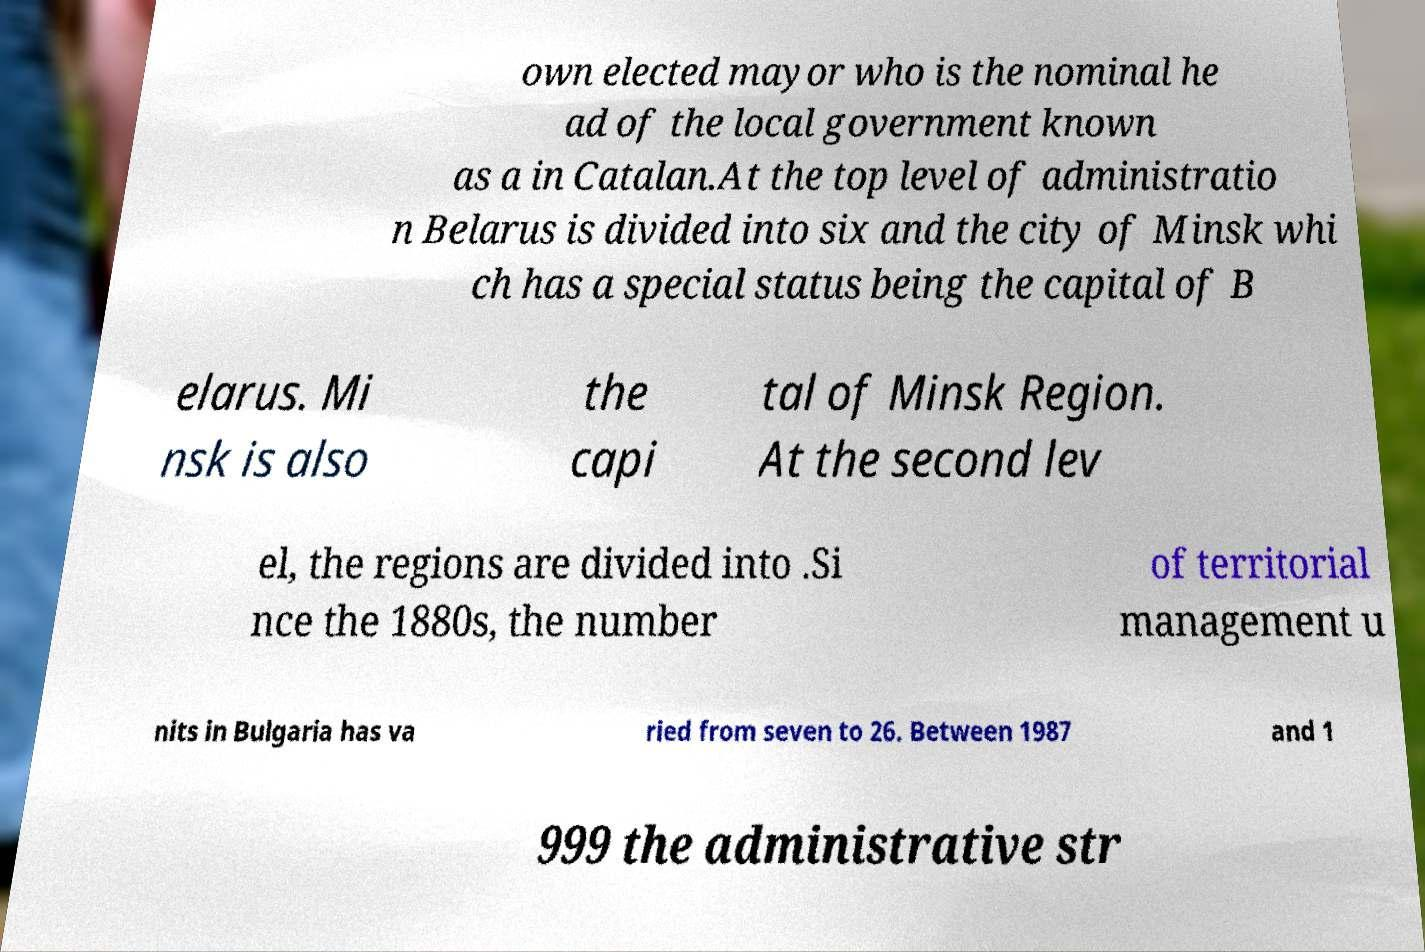What messages or text are displayed in this image? I need them in a readable, typed format. own elected mayor who is the nominal he ad of the local government known as a in Catalan.At the top level of administratio n Belarus is divided into six and the city of Minsk whi ch has a special status being the capital of B elarus. Mi nsk is also the capi tal of Minsk Region. At the second lev el, the regions are divided into .Si nce the 1880s, the number of territorial management u nits in Bulgaria has va ried from seven to 26. Between 1987 and 1 999 the administrative str 